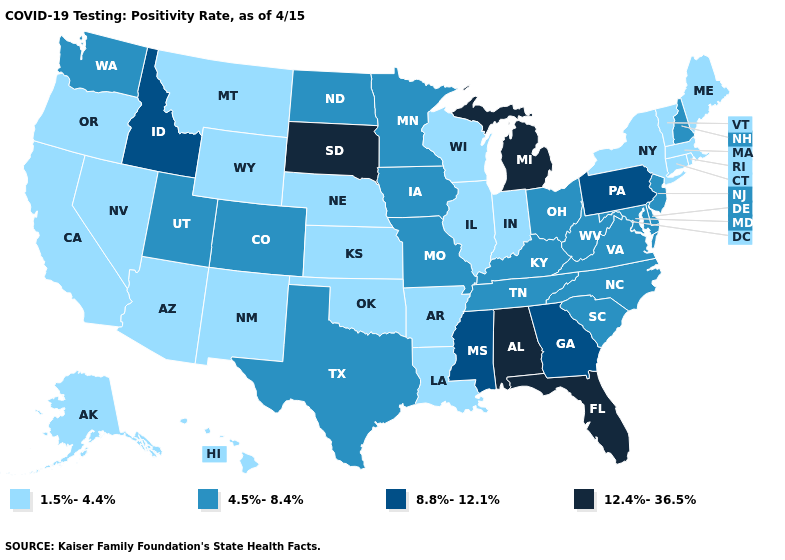Among the states that border Georgia , does Florida have the highest value?
Concise answer only. Yes. Does Illinois have the lowest value in the USA?
Concise answer only. Yes. How many symbols are there in the legend?
Answer briefly. 4. What is the lowest value in states that border New York?
Give a very brief answer. 1.5%-4.4%. Which states have the lowest value in the MidWest?
Short answer required. Illinois, Indiana, Kansas, Nebraska, Wisconsin. Does the first symbol in the legend represent the smallest category?
Quick response, please. Yes. Does the first symbol in the legend represent the smallest category?
Answer briefly. Yes. Name the states that have a value in the range 4.5%-8.4%?
Answer briefly. Colorado, Delaware, Iowa, Kentucky, Maryland, Minnesota, Missouri, New Hampshire, New Jersey, North Carolina, North Dakota, Ohio, South Carolina, Tennessee, Texas, Utah, Virginia, Washington, West Virginia. What is the highest value in the USA?
Give a very brief answer. 12.4%-36.5%. What is the highest value in the MidWest ?
Answer briefly. 12.4%-36.5%. Among the states that border Illinois , does Indiana have the lowest value?
Write a very short answer. Yes. What is the value of Iowa?
Quick response, please. 4.5%-8.4%. What is the lowest value in the MidWest?
Be succinct. 1.5%-4.4%. Does Pennsylvania have the highest value in the Northeast?
Give a very brief answer. Yes. What is the value of Illinois?
Keep it brief. 1.5%-4.4%. 